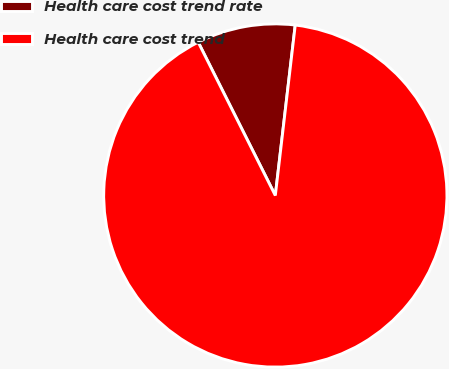Convert chart. <chart><loc_0><loc_0><loc_500><loc_500><pie_chart><fcel>Health care cost trend rate<fcel>Health care cost trend<nl><fcel>9.27%<fcel>90.73%<nl></chart> 